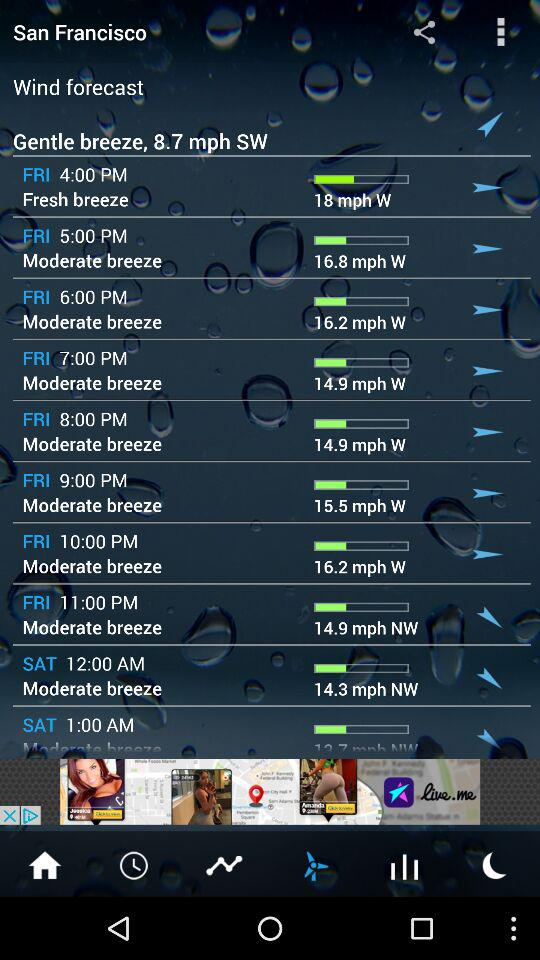What was the wind speed at 10 p.m. on Friday? The wind speed was 16.2 mph. 